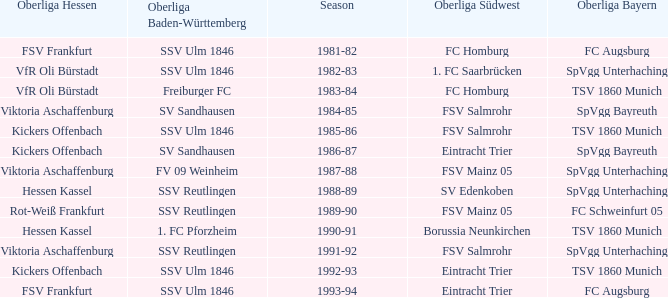Which oberliga baden-württemberg has a season of 1991-92? SSV Reutlingen. 